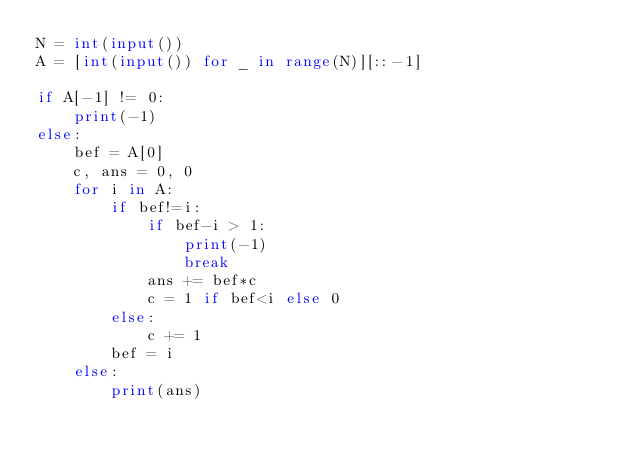<code> <loc_0><loc_0><loc_500><loc_500><_Python_>N = int(input())
A = [int(input()) for _ in range(N)][::-1]

if A[-1] != 0:
    print(-1)
else:
    bef = A[0]
    c, ans = 0, 0
    for i in A:
        if bef!=i:
            if bef-i > 1:
                print(-1)
                break
            ans += bef*c
            c = 1 if bef<i else 0
        else:
            c += 1
        bef = i
    else:
        print(ans)</code> 